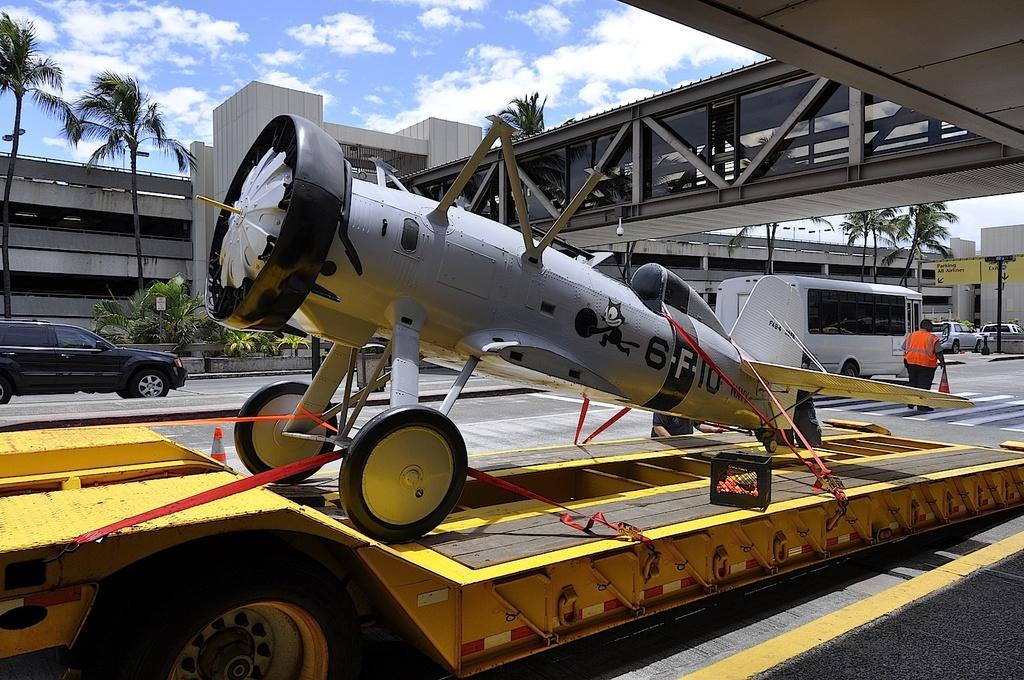<image>
Give a short and clear explanation of the subsequent image. Airplane sitting on the trailer with the call letters 6-F-10 